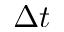<formula> <loc_0><loc_0><loc_500><loc_500>\Delta t</formula> 